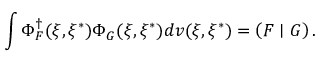Convert formula to latex. <formula><loc_0><loc_0><loc_500><loc_500>\int \Phi _ { F } ^ { \dagger } ( \xi , \xi ^ { * } ) \Phi _ { G } ( \xi , \xi ^ { * } ) d v ( \xi , \xi ^ { * } ) = \left ( F | G \right ) .</formula> 